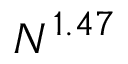Convert formula to latex. <formula><loc_0><loc_0><loc_500><loc_500>N ^ { 1 . 4 7 }</formula> 